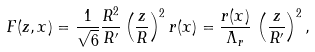Convert formula to latex. <formula><loc_0><loc_0><loc_500><loc_500>F ( z , x ) = \frac { 1 } { \sqrt { 6 } } \frac { R ^ { 2 } } { R ^ { \prime } } \left ( \frac { z } { R } \right ) ^ { 2 } r ( x ) = \frac { r ( x ) } { \Lambda _ { r } } \, \left ( \frac { z } { R ^ { \prime } } \right ) ^ { 2 } ,</formula> 